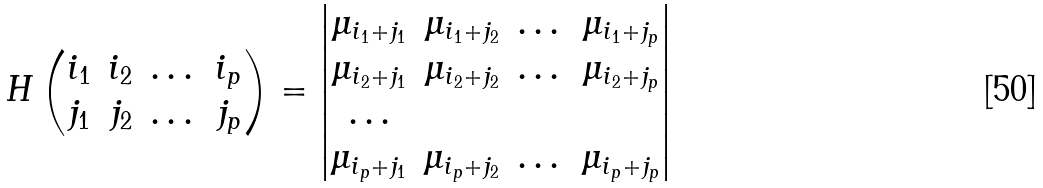Convert formula to latex. <formula><loc_0><loc_0><loc_500><loc_500>H \begin{pmatrix} i _ { 1 } & i _ { 2 } & \dots & i _ { p } \\ j _ { 1 } & j _ { 2 } & \dots & j _ { p } \end{pmatrix} = \begin{vmatrix} \mu _ { i _ { 1 } + j _ { 1 } } & \mu _ { i _ { 1 } + j _ { 2 } } & \dots & \mu _ { i _ { 1 } + j _ { p } } \\ \mu _ { i _ { 2 } + j _ { 1 } } & \mu _ { i _ { 2 } + j _ { 2 } } & \dots & \mu _ { i _ { 2 } + j _ { p } } \\ \dots \\ \mu _ { i _ { p } + j _ { 1 } } & \mu _ { i _ { p } + j _ { 2 } } & \dots & \mu _ { i _ { p } + j _ { p } } \end{vmatrix}</formula> 